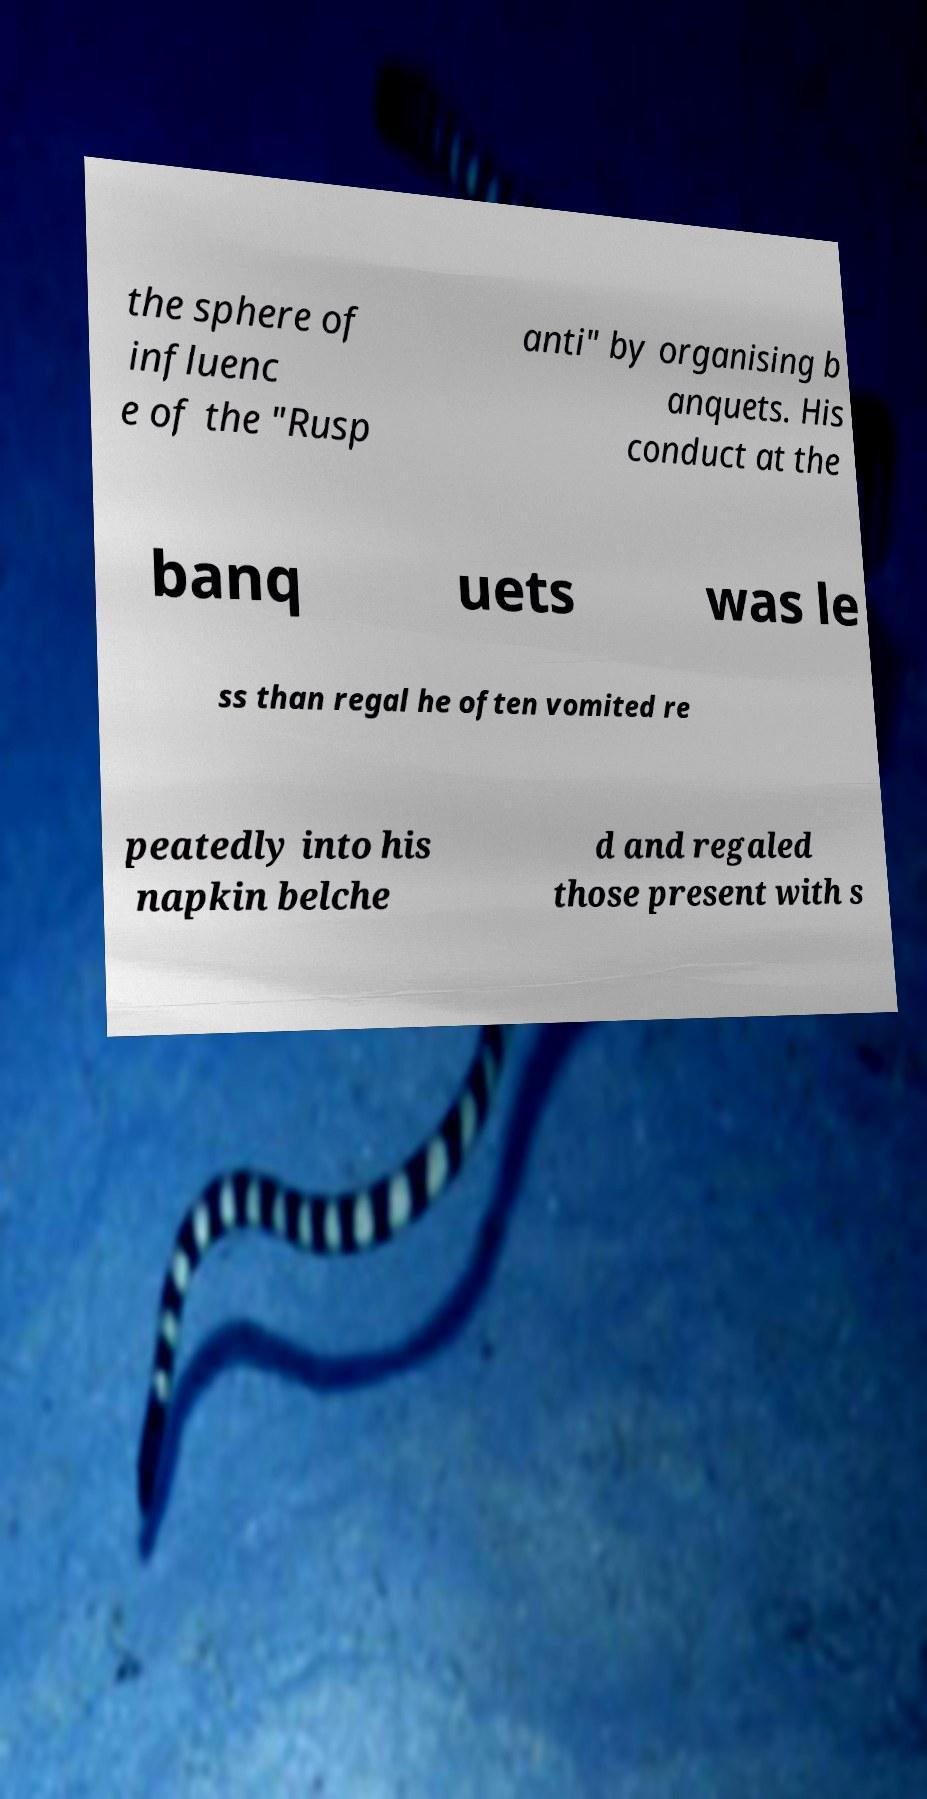Could you assist in decoding the text presented in this image and type it out clearly? the sphere of influenc e of the "Rusp anti" by organising b anquets. His conduct at the banq uets was le ss than regal he often vomited re peatedly into his napkin belche d and regaled those present with s 